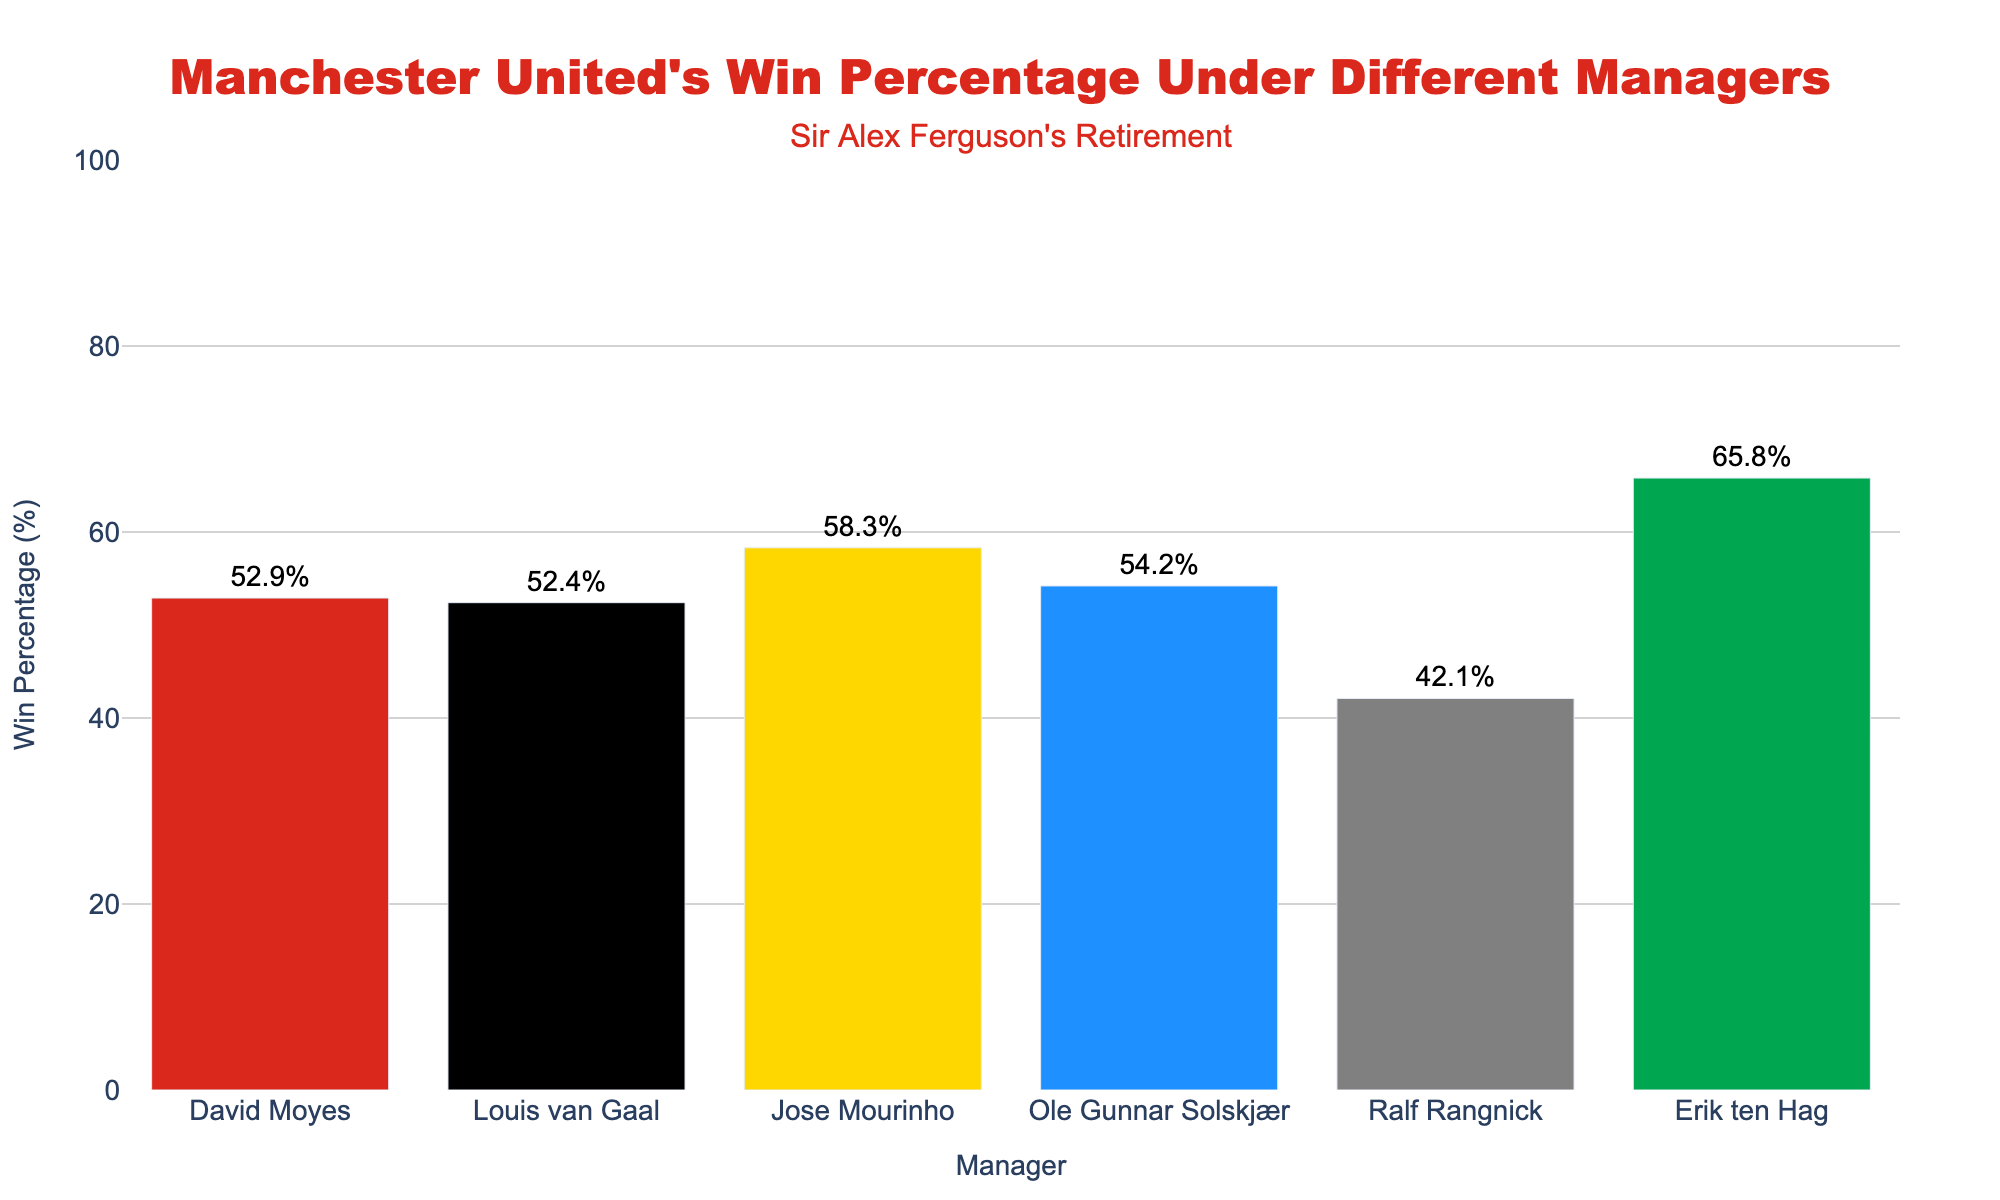Which manager had the highest win percentage since Sir Alex Ferguson's retirement? Looking at the highest bar in the chart, Erik ten Hag has the highest win percentage.
Answer: Erik ten Hag Which manager had the lowest win percentage? The bar representing Ralf Rangnick is the shortest, indicating he had the lowest win percentage.
Answer: Ralf Rangnick How much higher is Erik ten Hag's win percentage compared to Ole Gunnar Solskjær's? Erik ten Hag's win percentage is 65.8% while Ole Gunnar Solskjær's is 54.2%. Subtracting the two gives 65.8% - 54.2% = 11.6%.
Answer: 11.6% Who had a higher win percentage, David Moyes or Louis van Gaal? Comparing the heights of the bars, David Moyes' (52.9%) is slightly higher than Louis van Gaal's (52.4%).
Answer: David Moyes What is the average win percentage of managers after Sir Alex Ferguson's retirement? Summing the win percentages and dividing by the number of managers: (52.9% + 52.4% + 58.3% + 54.2% + 42.1% + 65.8%) / 6 managers = 54.28%.
Answer: 54.28% Compare the win percentages of Jose Mourinho and Louis van Gaal. Who was more successful? Jose Mourinho's win percentage is 58.3% compared to Louis van Gaal's 52.4%. Thus, Jose Mourinho was more successful.
Answer: Jose Mourinho What is the difference in win percentage between the manager with the highest percentage and the manager with the lowest percentage? Erik ten Hag's 65.8% minus Ralf Rangnick's 42.1% gives a difference of 23.7%.
Answer: 23.7% How does Ole Gunnar Solskjær's win percentage compare to the overall average win percentage post-Ferguson? The average win percentage is 54.28%, and Ole Gunnar Solskjær's win percentage is 54.2%. 54.2% is slightly below 54.28%.
Answer: Slightly below Which manager had a win percentage closest to 50%? Both David Moyes (52.9%) and Louis van Gaal (52.4%) are close to 50%, but Louis van Gaal is closest.
Answer: Louis van Gaal In terms of win percentage, how does Erik ten Hag compare with all other managers combined? First, find the combined win percentage by summing all managers' win percentages and subtracting Erik ten Hag’s: (52.9% + 52.4% + 58.3% + 54.2% + 42.1%) / 5 = 52.0%. Erik ten Hag's win percentage (65.8%) is significantly higher.
Answer: Significantly higher 